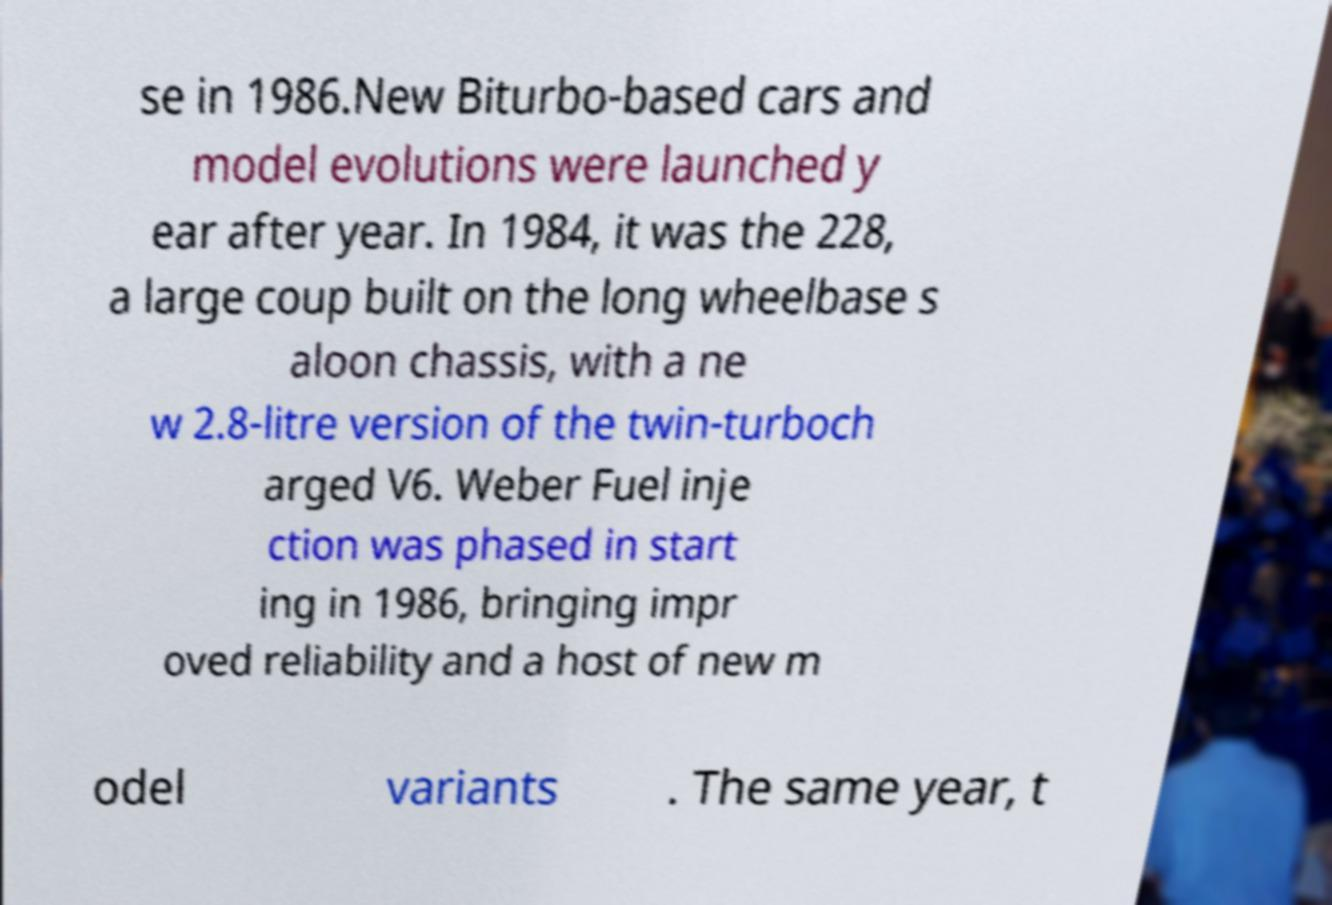Could you extract and type out the text from this image? se in 1986.New Biturbo-based cars and model evolutions were launched y ear after year. In 1984, it was the 228, a large coup built on the long wheelbase s aloon chassis, with a ne w 2.8-litre version of the twin-turboch arged V6. Weber Fuel inje ction was phased in start ing in 1986, bringing impr oved reliability and a host of new m odel variants . The same year, t 